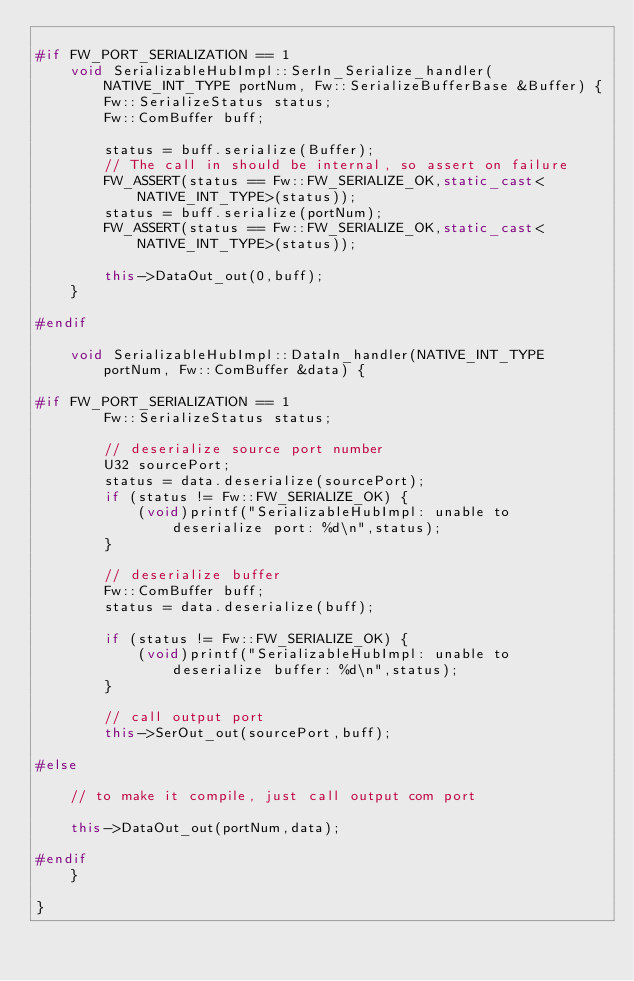Convert code to text. <code><loc_0><loc_0><loc_500><loc_500><_C++_>	
#if FW_PORT_SERIALIZATION == 1
    void SerializableHubImpl::SerIn_Serialize_handler(NATIVE_INT_TYPE portNum, Fw::SerializeBufferBase &Buffer) {
        Fw::SerializeStatus status;
        Fw::ComBuffer buff;

        status = buff.serialize(Buffer);
        // The call in should be internal, so assert on failure
        FW_ASSERT(status == Fw::FW_SERIALIZE_OK,static_cast<NATIVE_INT_TYPE>(status));
        status = buff.serialize(portNum);
        FW_ASSERT(status == Fw::FW_SERIALIZE_OK,static_cast<NATIVE_INT_TYPE>(status));

        this->DataOut_out(0,buff);
    }

#endif

    void SerializableHubImpl::DataIn_handler(NATIVE_INT_TYPE portNum, Fw::ComBuffer &data) {

#if FW_PORT_SERIALIZATION == 1
        Fw::SerializeStatus status;

        // deserialize source port number
        U32 sourcePort;
        status = data.deserialize(sourcePort);
        if (status != Fw::FW_SERIALIZE_OK) {
            (void)printf("SerializableHubImpl: unable to deserialize port: %d\n",status);
        }

        // deserialize buffer
        Fw::ComBuffer buff;
        status = data.deserialize(buff);

        if (status != Fw::FW_SERIALIZE_OK) {
            (void)printf("SerializableHubImpl: unable to deserialize buffer: %d\n",status);
        }

        // call output port
        this->SerOut_out(sourcePort,buff);

#else

    // to make it compile, just call output com port

    this->DataOut_out(portNum,data);

#endif
    }

}
</code> 